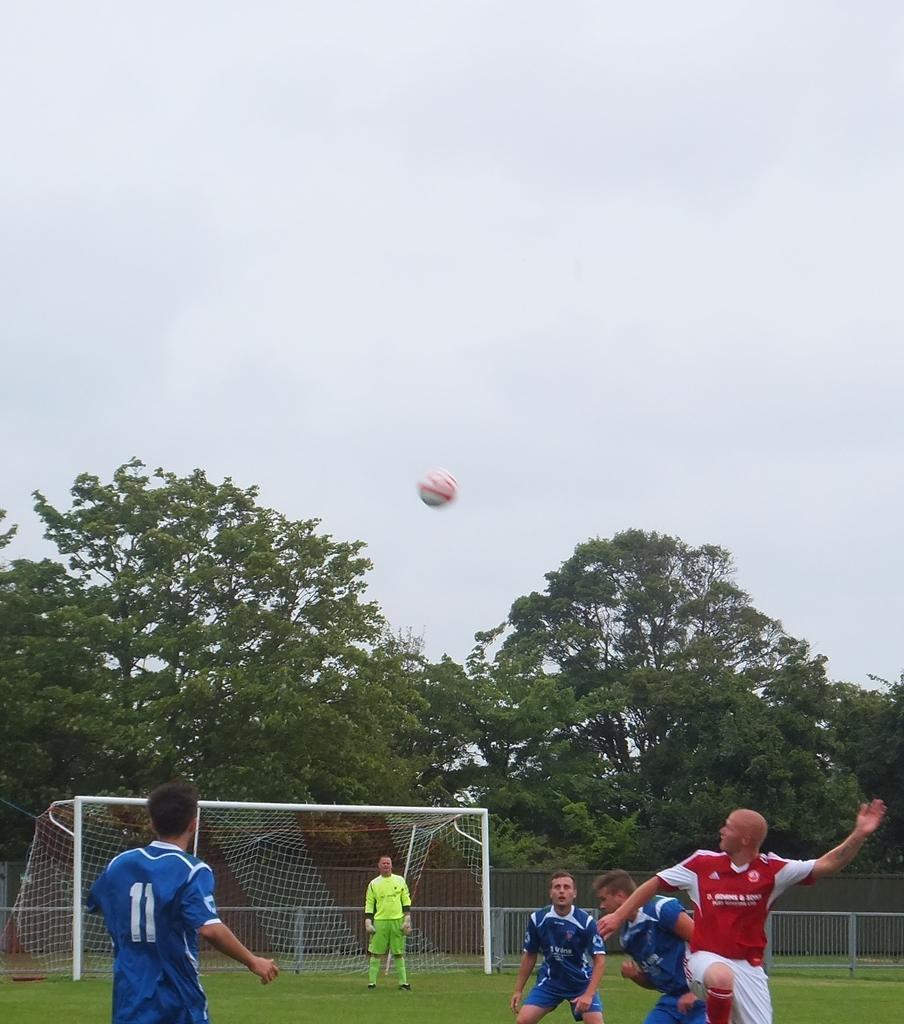In one or two sentences, can you explain what this image depicts? In the picture a group of people are playing football in the ground and behind the ground there are many trees. 